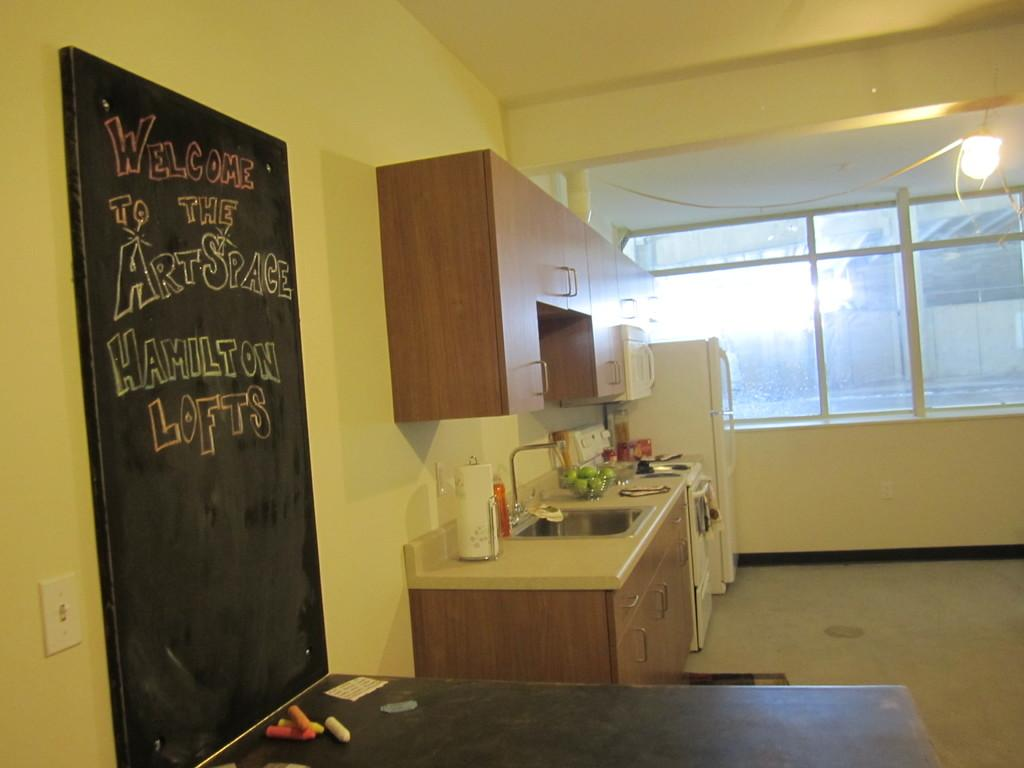<image>
Share a concise interpretation of the image provided. A kitchen has a blackboard that says welcome to the Art Space. 